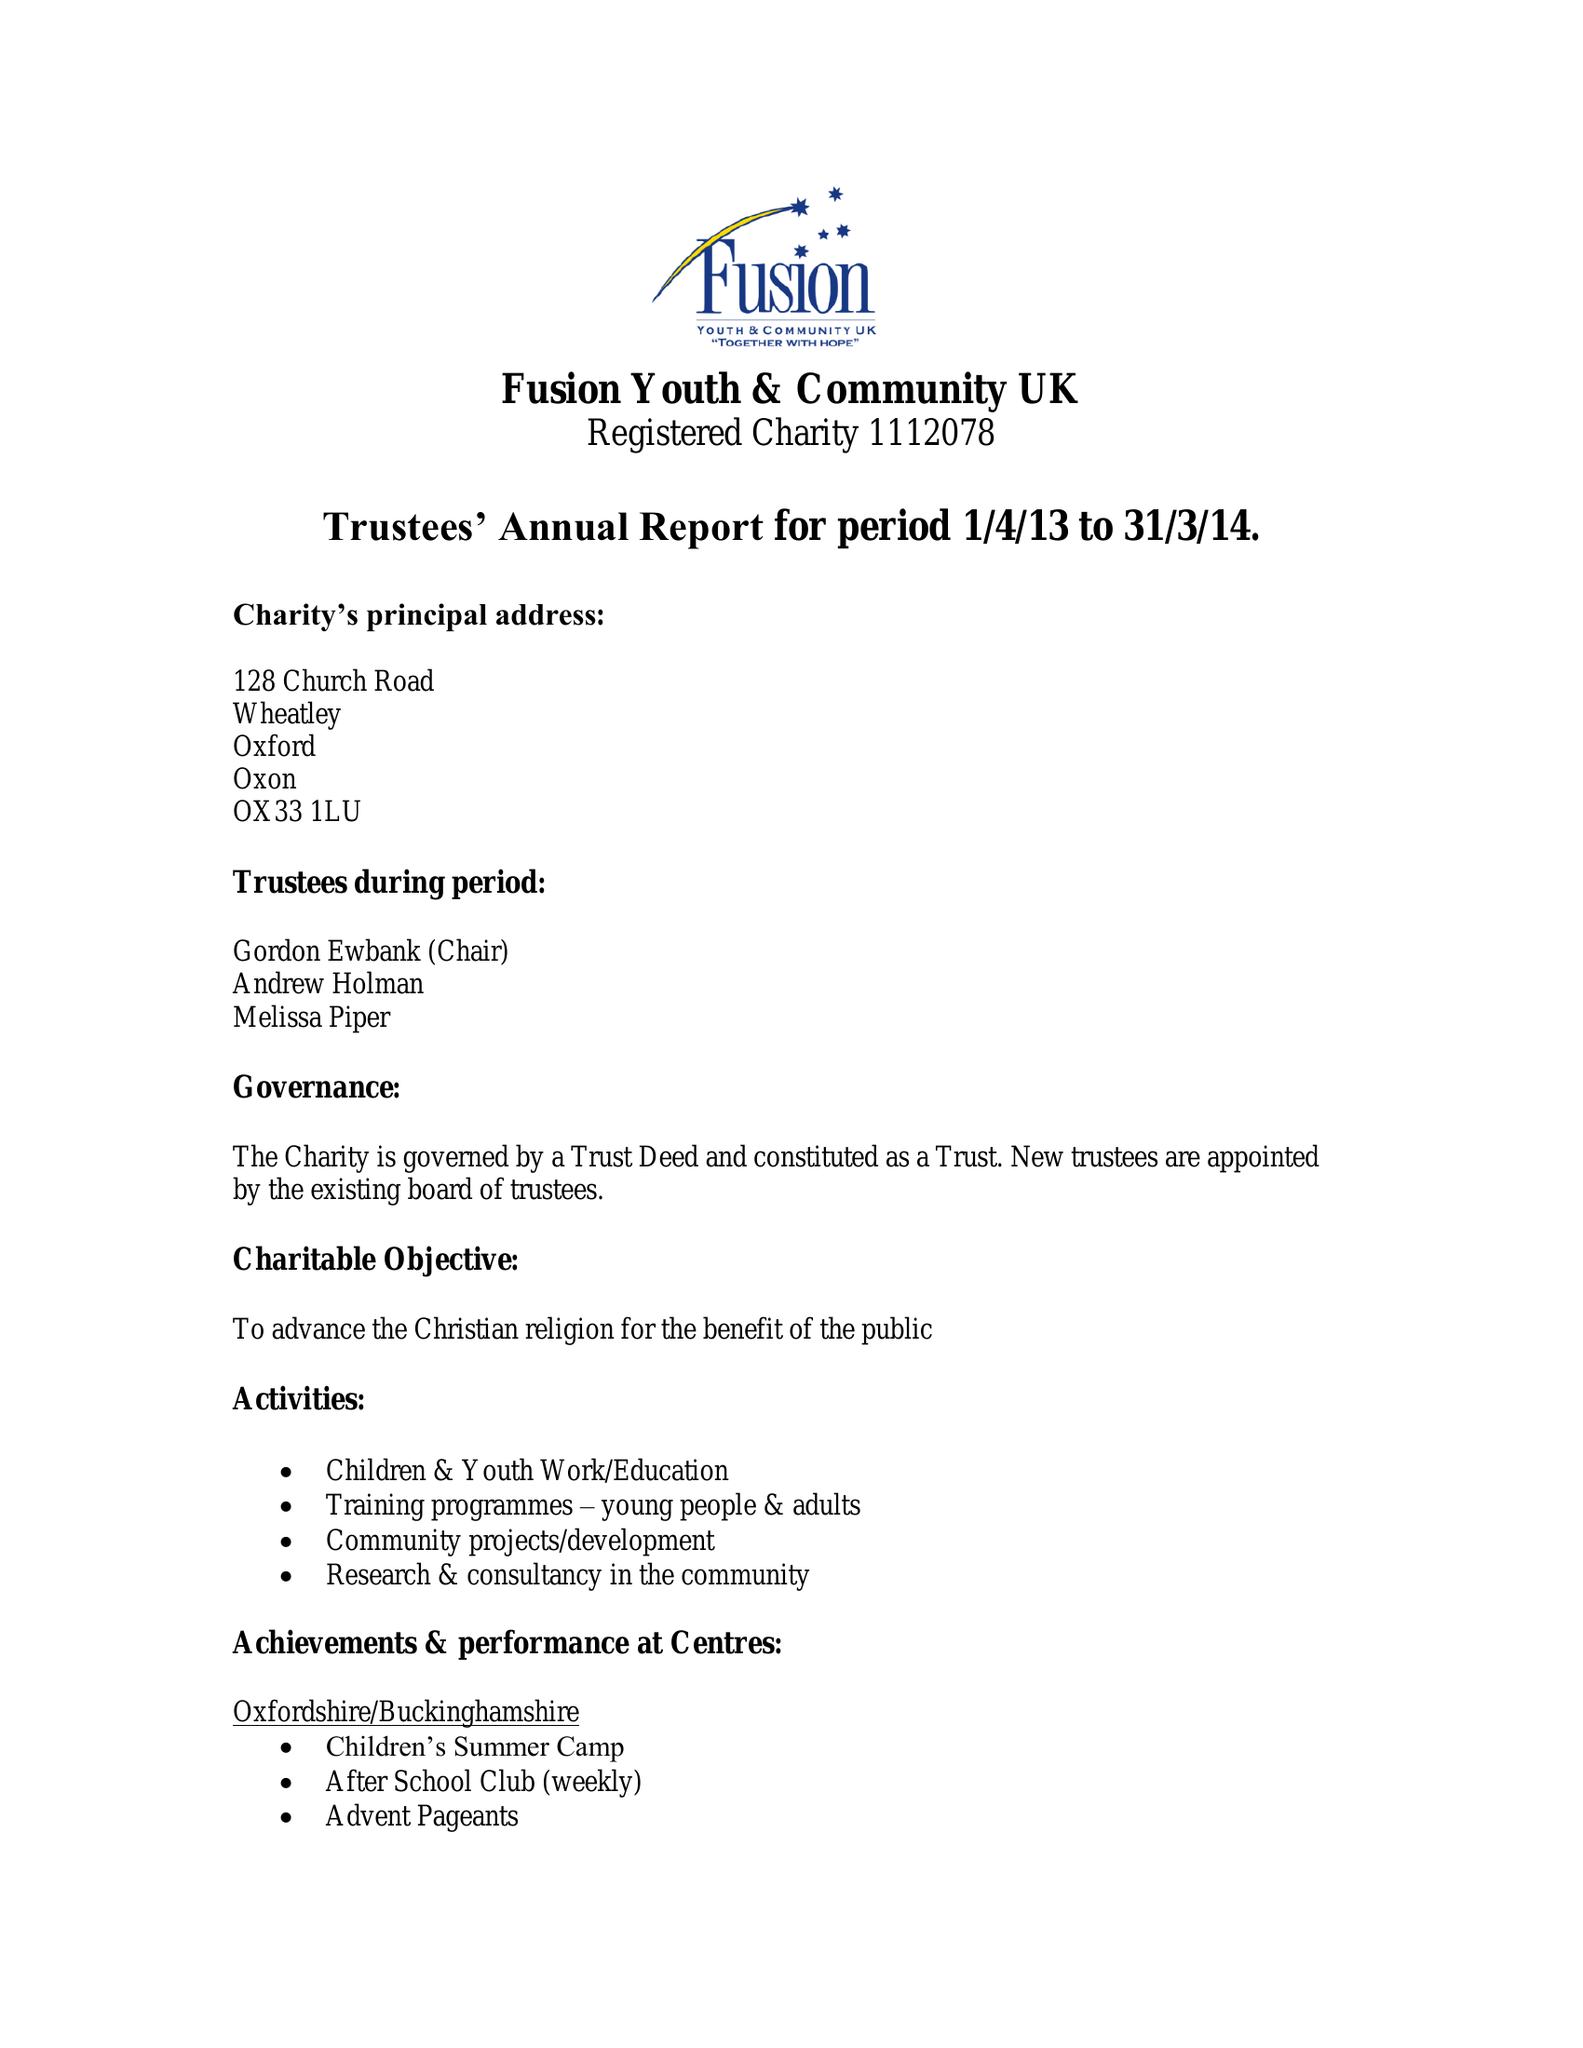What is the value for the address__post_town?
Answer the question using a single word or phrase. READING 